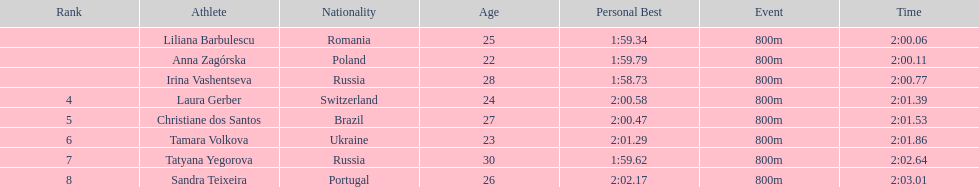The last runner crossed the finish line in 2:03.01. what was the previous time for the 7th runner? 2:02.64. 